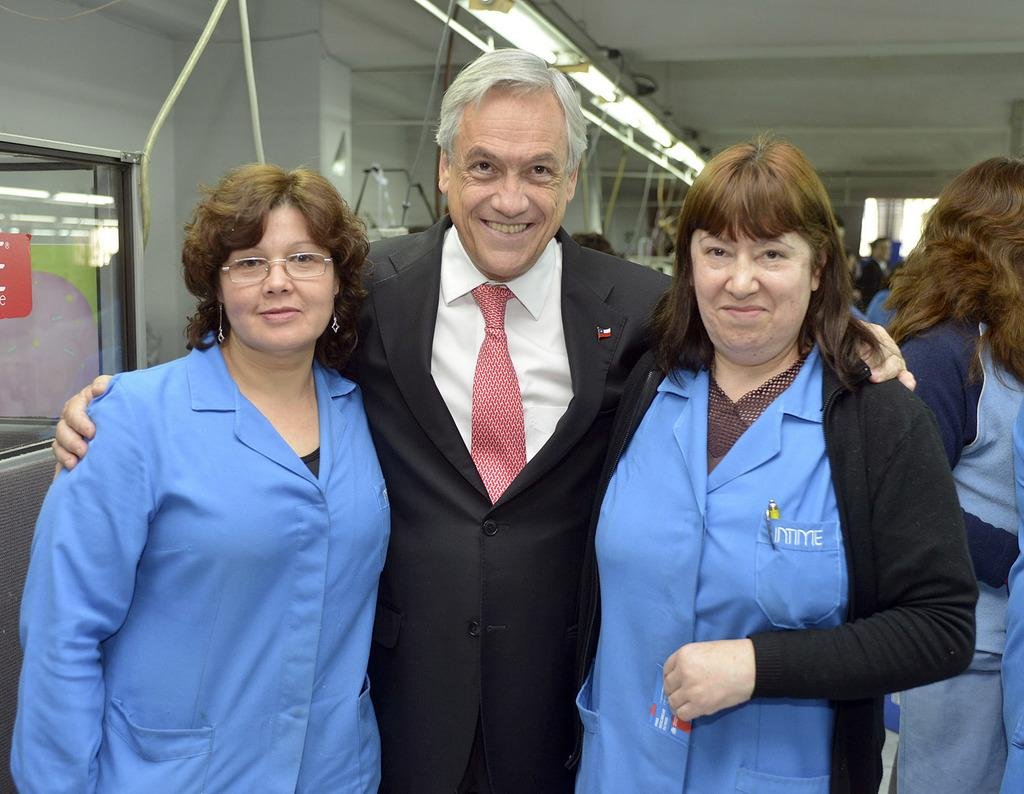Who is the main subject in the image? There is an old man in the image. What is the old man wearing? The old man is wearing a black suit. Who is standing next to the old man? The old man is standing between two women. What are the two women wearing? The two women are wearing blue aprons. How many people are visible behind the old man and the two women? There are many people standing behind the old man and the two women. What can be seen on the ceiling in the image? There are lights on the ceiling in the image. What type of amusement can be seen in the image? There is no amusement present in the image; it features an old man, two women, and a group of people. How many legs does the old man have in the image? The old man has two legs in the image, as is typical for humans. 